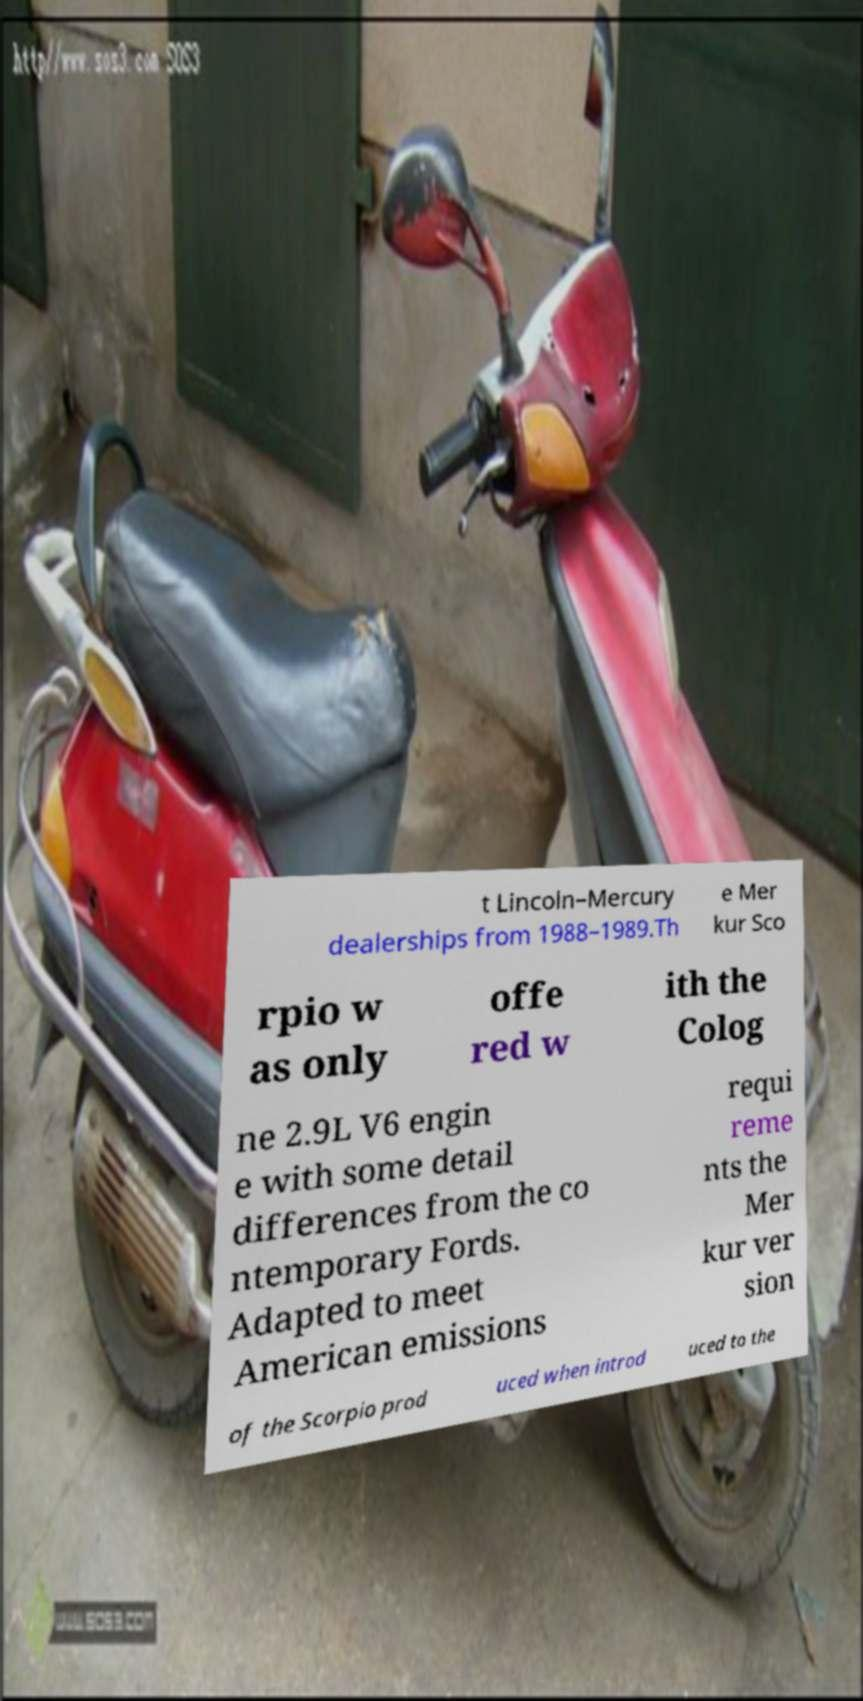Please identify and transcribe the text found in this image. t Lincoln–Mercury dealerships from 1988–1989.Th e Mer kur Sco rpio w as only offe red w ith the Colog ne 2.9L V6 engin e with some detail differences from the co ntemporary Fords. Adapted to meet American emissions requi reme nts the Mer kur ver sion of the Scorpio prod uced when introd uced to the 